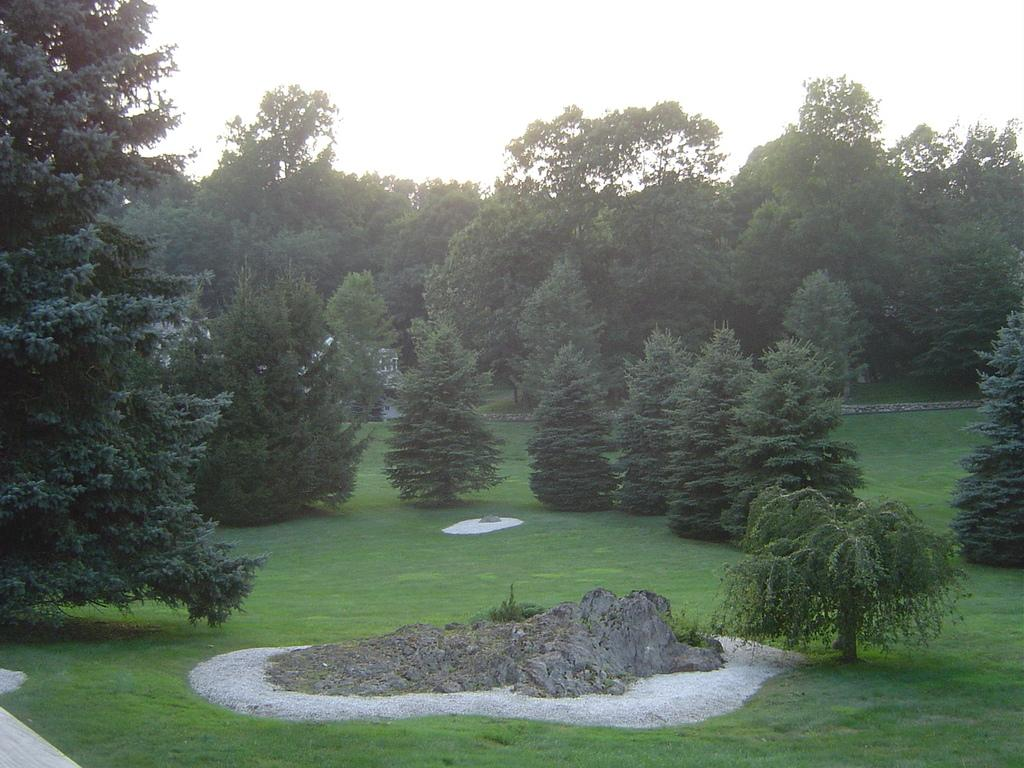What type of vegetation is visible in the image? There is grass in the image. What other natural elements can be seen in the image? There are trees in the image. What type of man-made structures are present in the image? There are houses in the image. What type of quilt is being used to cover the trees in the image? There is no quilt present in the image, and the trees are not covered by any fabric. How many pins are visible holding the grass together in the image? There are no pins visible in the image; the grass is not held together by any pins. 